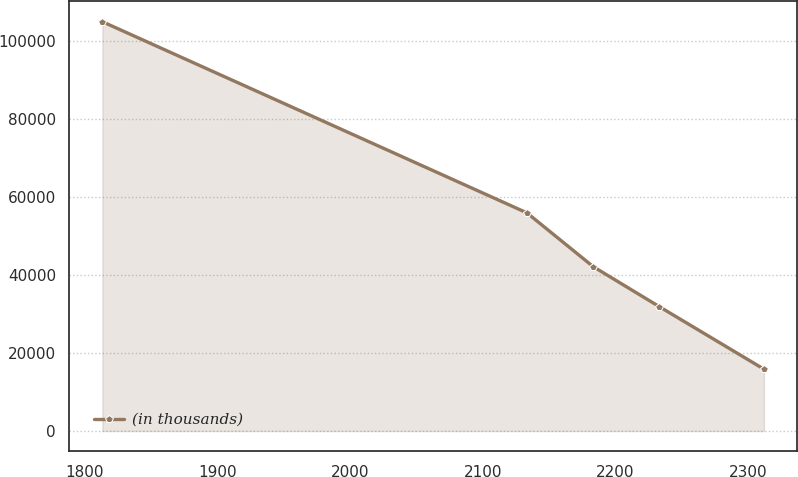Convert chart. <chart><loc_0><loc_0><loc_500><loc_500><line_chart><ecel><fcel>(in thousands)<nl><fcel>1813.19<fcel>104953<nl><fcel>2133.17<fcel>55932.1<nl><fcel>2183.03<fcel>42162.8<nl><fcel>2232.89<fcel>31890.6<nl><fcel>2311.8<fcel>15851.2<nl></chart> 